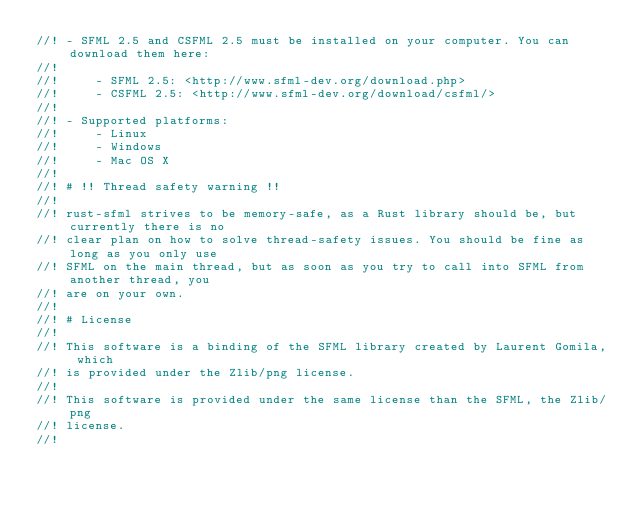<code> <loc_0><loc_0><loc_500><loc_500><_Rust_>//! - SFML 2.5 and CSFML 2.5 must be installed on your computer. You can download them here:
//!
//!     - SFML 2.5: <http://www.sfml-dev.org/download.php>
//!     - CSFML 2.5: <http://www.sfml-dev.org/download/csfml/>
//!
//! - Supported platforms:
//!     - Linux
//!     - Windows
//!     - Mac OS X
//!
//! # !! Thread safety warning !!
//!
//! rust-sfml strives to be memory-safe, as a Rust library should be, but currently there is no
//! clear plan on how to solve thread-safety issues. You should be fine as long as you only use
//! SFML on the main thread, but as soon as you try to call into SFML from another thread, you
//! are on your own.
//!
//! # License
//!
//! This software is a binding of the SFML library created by Laurent Gomila, which
//! is provided under the Zlib/png license.
//!
//! This software is provided under the same license than the SFML, the Zlib/png
//! license.
//!
</code> 